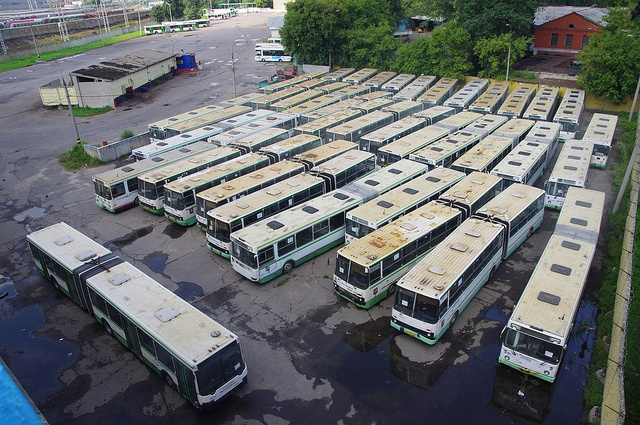Describe the objects in this image and their specific colors. I can see bus in gray, lightgray, and darkgray tones, bus in gray, black, lightgray, and darkgray tones, bus in gray, lightgray, darkgray, and black tones, bus in gray, black, tan, lightgray, and darkgray tones, and bus in gray, lightgray, black, and darkgray tones in this image. 